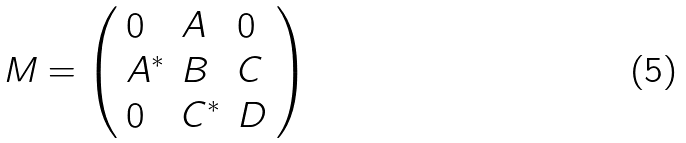<formula> <loc_0><loc_0><loc_500><loc_500>M = \left ( \begin{array} { l l l } 0 & A & 0 \\ A ^ { * } & B & C \\ 0 & C ^ { * } & D \end{array} \right )</formula> 